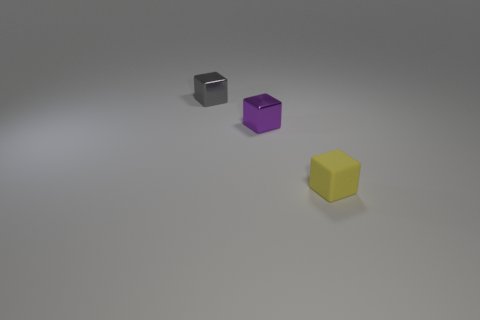What could be the potential use or context for these objects? These objects appear to be artistic renderings and could be used for various purposes such as elements in a graphic design project, pieces for a board game, or as visual aids in an educational setting to discuss concepts like geometry or the effects of light on different surfaces. 